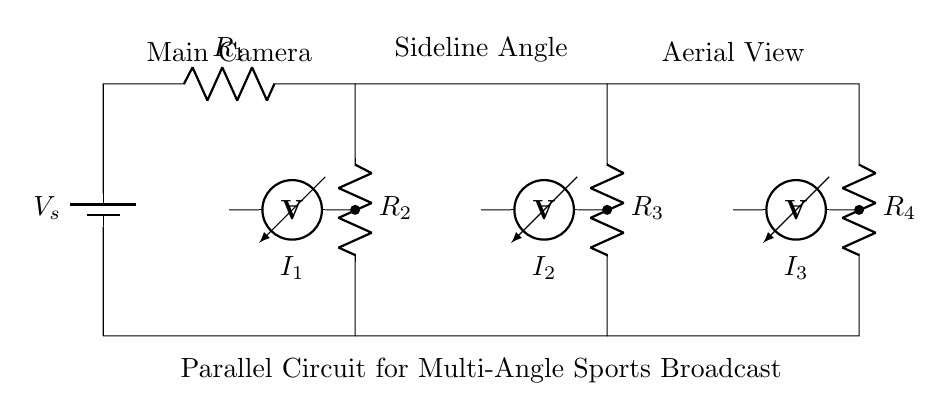What is the total number of resistors in this circuit? The circuit diagram shows four resistors labeled as R1, R2, R3, and R4, which are clearly marked in the diagram.
Answer: four What type of circuit is shown in the diagram? The diagram features a parallel circuit configuration because the current is divided among multiple branches with resistors in parallel, indicating that each camera angle receives a separate current.
Answer: parallel Which camera angle has the highest current flow? The camera angles are labeled, and the labeling implies that the main camera would likely receive the most current due to its primary role in broadcasting, while sideline angle and aerial view would receive less current corresponding to their additional roles.
Answer: main camera What is the role of the ammeters in the circuit? Ammeters are used to measure the current flowing through each branch of the circuit, and they are placed in series with each resistor to accurately gauge the current specific to each camera angle.
Answer: measure current How many camera angles are represented in the circuit? The circuit diagram labels three camera angles: Main Camera, Sideline Angle, and Aerial View, counting each as a separate branch connected to the parallel configuration.
Answer: three What is the relationship between voltage and resistance in this circuit? In a parallel circuit, the voltage across each branch (resistor) is the same and equal to the source voltage. However, the current through each branch depends on the resistance, following Ohm's Law, where less resistance results in higher current.
Answer: same voltage What does the current divider principle imply for this circuit? The current divider principle states that in a parallel circuit, the total current supplied from the source divides among the parallel branches according to the resistance values; lower resistance branches take a larger share of the total current.
Answer: divide current 